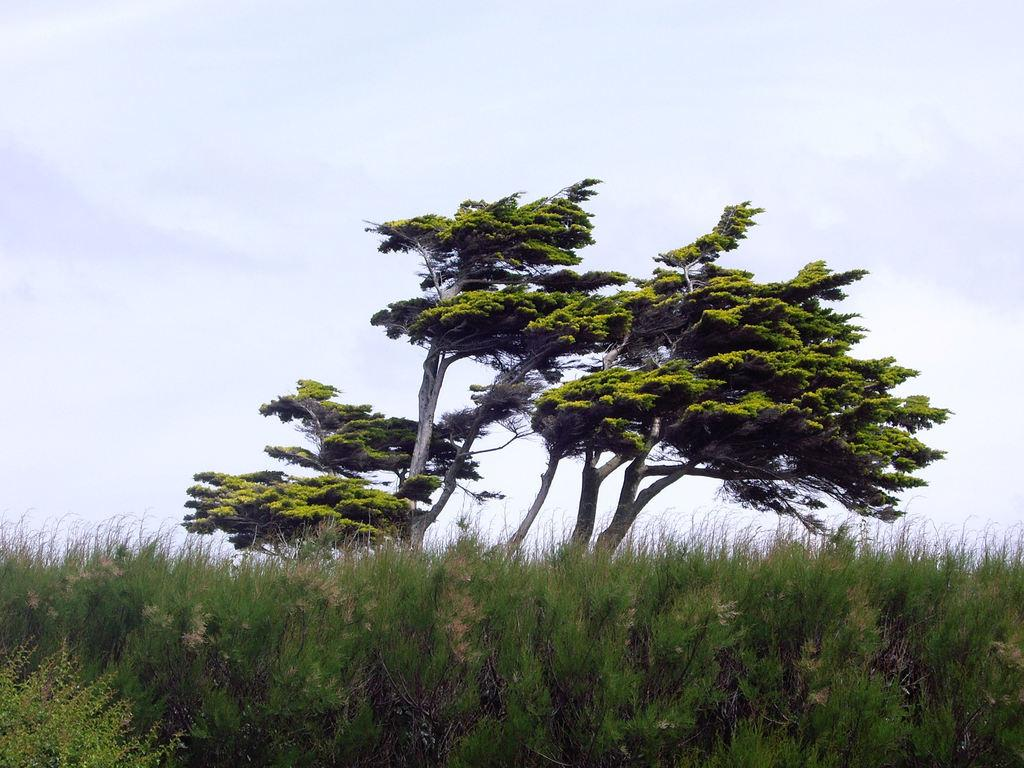What type of vegetation can be seen in the image? There are trees and plants in the image. What part of the natural environment is visible in the image? The sky is visible in the image. What type of drink is being served to the grape in the image? There is no grape or drink present in the image. Can you tell me where the birth of the new plant is taking place in the image? There is no depiction of a plant's birth in the image; it only features trees and plants. 